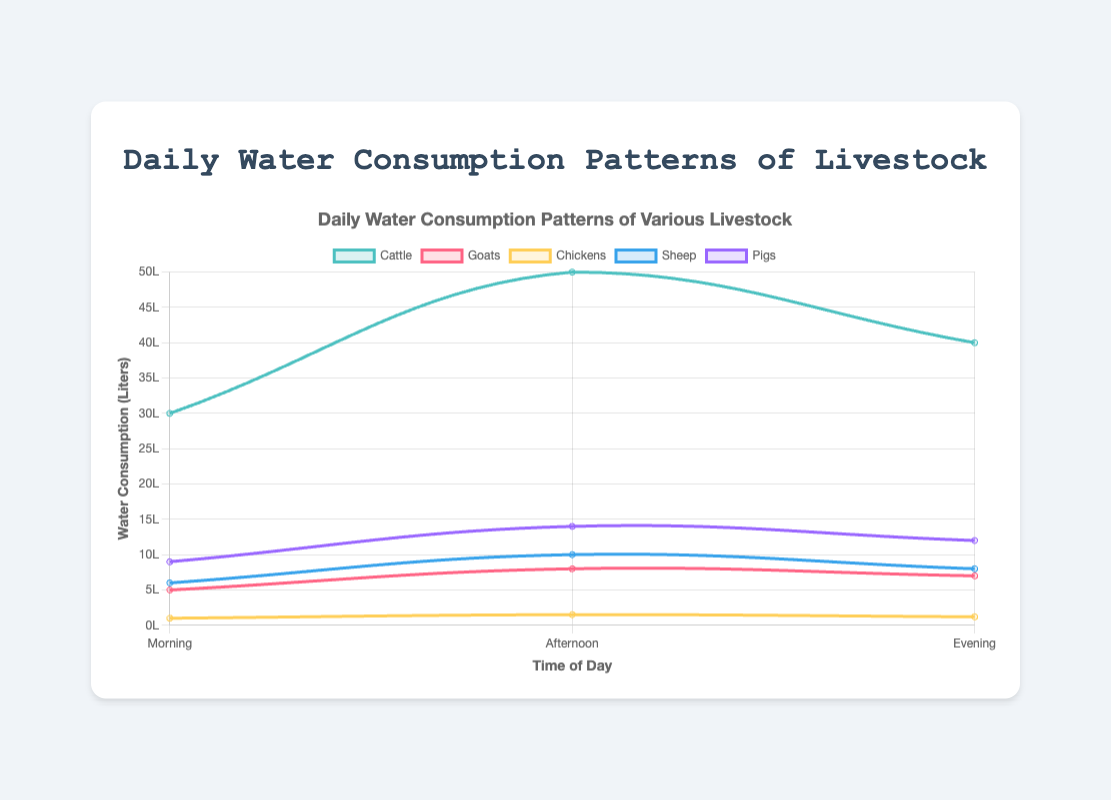Which livestock type consumes the most water in the afternoon? By looking at the afternoon consumption data points, we can see that the Cattle have the highest value at 50 liters.
Answer: Cattle How much more water do Pigs consume in the evening compared to Goats in the morning? Pigs consume 12 liters in the evening, and Goats consume 5 liters in the morning. The difference is 12 - 5 = 7 liters.
Answer: 7 liters What is the total daily water consumption for Chickens? Chickens consume 1 liter in the morning, 1.5 liters in the afternoon, and 1.2 liters in the evening. The total daily consumption is 1 + 1.5 + 1.2 = 3.7 liters.
Answer: 3.7 liters Which two livestock types have the closest water consumption values in the morning? Comparing the morning consumption values, Goats with 5 liters and Sheep with 6 liters are the closest.
Answer: Goats and Sheep Do Sheep drink more water in the afternoon than Pigs in the morning? Sheep consume 10 liters in the afternoon, while Pigs consume 9 liters in the morning. Since 10 liters is more than 9 liters, the answer is yes.
Answer: Yes What is the average water consumption of Sheep throughout the day? Sheep consume 6 liters in the morning, 10 liters in the afternoon, and 8 liters in the evening. The average is (6 + 10 + 8)/3 = 8 liters.
Answer: 8 liters Which time period shows the highest water consumption for Cattle? By comparing the morning (30 liters), afternoon (50 liters), and evening (40 liters), the highest consumption is in the afternoon.
Answer: Afternoon How much more water does Cattle consume in the afternoon compared to Sheep in the evening? Cattle consume 50 liters in the afternoon, and Sheep consume 8 liters in the evening. The difference is 50 - 8 = 42 liters.
Answer: 42 liters What is the difference in evening water consumption between the livestock type that consumes the most and the type that consumes the least? Cattle consume the most in the evening with 40 liters, and Chickens consume the least with 1.2 liters. The difference is 40 - 1.2 = 38.8 liters.
Answer: 38.8 liters 